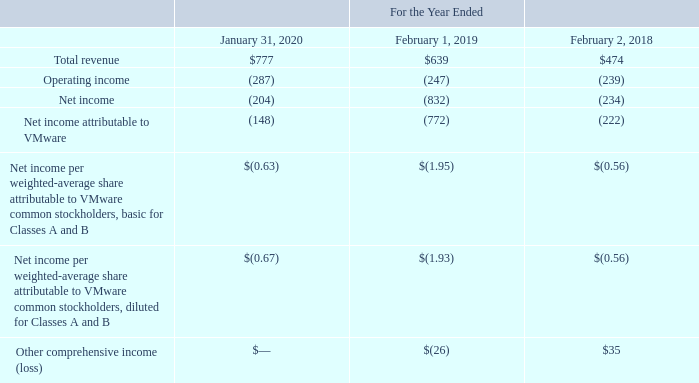The purchase was accounted for as a transaction between entities under common control. Assets and liabilities transferred were recorded at historical carrying amounts of Pivotal on the date of the transfer, except for certain goodwill and intangible assets that were recorded in the amounts previously recognized by Dell for Pivotal in connection with Dell’s acquisition of EMC during fiscal 2016. VMware’s previous investment in Pivotal, including any unrealized gain or loss previously recognized in other income (expense), net on the consolidated statements of income, were derecognized. Transactions with Pivotal that were previously accounted for as transactions between related parties were eliminated in the consolidated financial statements for all periods presented. All intercompany transactions and account balances between VMware and Pivotal have been eliminated upon consolidation for all periods presented.
The effect of the change from the combination to the consolidated statements of income was as follows (amounts in millions, except per share amounts):
What was the total revenue in 2020?
Answer scale should be: million. 777. What was the net income in 2018?
Answer scale should be: million. (234). Which years does the table provide information for the effect of the change from the combination to the consolidated statements of income? 2020, 2019, 2018. What was the change in total revenue between 2018 and 2019?
Answer scale should be: million. 639-474
Answer: 165. How many years did total revenue exceed $500 million? 2020##2019
Answer: 2. What was the percentage change in net income between 2019 and 2020?
Answer scale should be: percent. (-204-(-832))/-832
Answer: -75.48. 